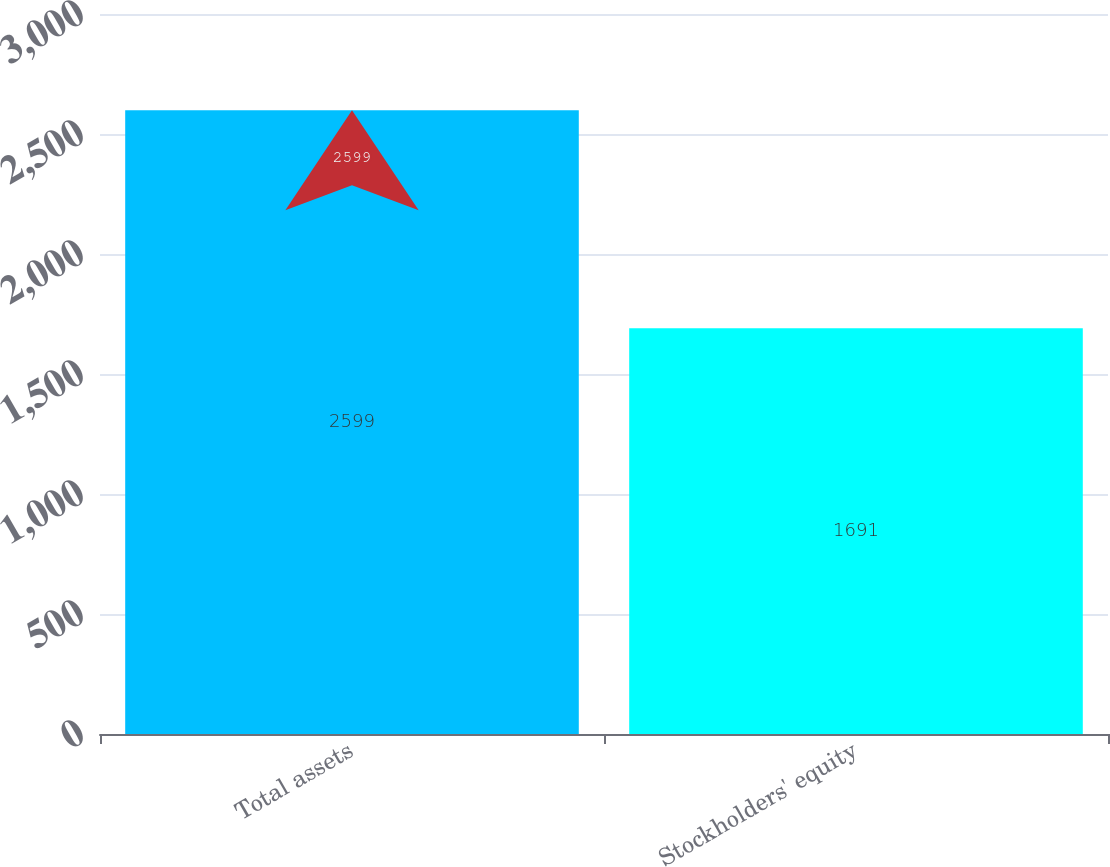Convert chart. <chart><loc_0><loc_0><loc_500><loc_500><bar_chart><fcel>Total assets<fcel>Stockholders' equity<nl><fcel>2599<fcel>1691<nl></chart> 